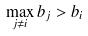Convert formula to latex. <formula><loc_0><loc_0><loc_500><loc_500>\max _ { j \ne i } b _ { j } > b _ { i }</formula> 